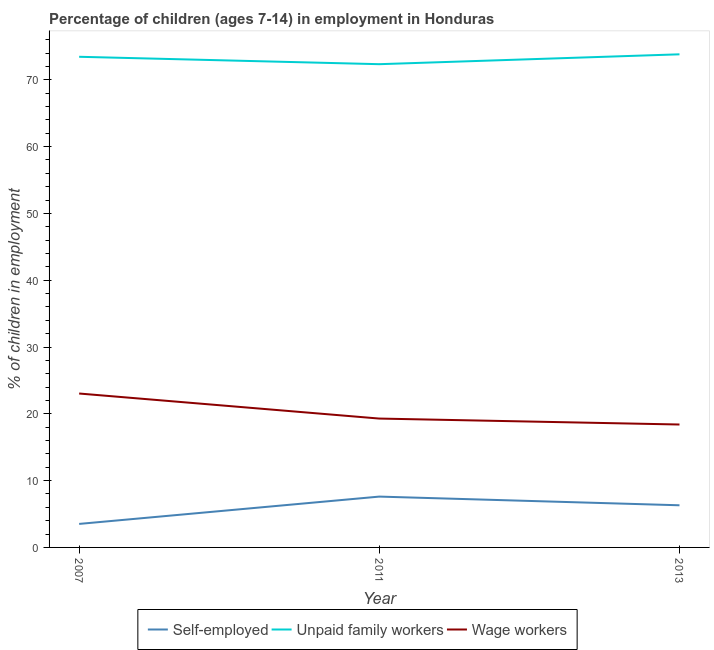How many different coloured lines are there?
Your answer should be compact. 3. Is the number of lines equal to the number of legend labels?
Give a very brief answer. Yes. What is the percentage of children employed as unpaid family workers in 2013?
Offer a terse response. 73.82. Across all years, what is the maximum percentage of self employed children?
Your response must be concise. 7.61. Across all years, what is the minimum percentage of children employed as wage workers?
Give a very brief answer. 18.4. In which year was the percentage of children employed as unpaid family workers minimum?
Ensure brevity in your answer.  2011. What is the total percentage of children employed as unpaid family workers in the graph?
Offer a very short reply. 219.61. What is the difference between the percentage of children employed as wage workers in 2011 and that in 2013?
Your response must be concise. 0.89. What is the difference between the percentage of self employed children in 2013 and the percentage of children employed as unpaid family workers in 2007?
Ensure brevity in your answer.  -67.14. What is the average percentage of children employed as wage workers per year?
Your answer should be very brief. 20.24. In the year 2007, what is the difference between the percentage of children employed as unpaid family workers and percentage of children employed as wage workers?
Your answer should be compact. 50.41. What is the ratio of the percentage of self employed children in 2007 to that in 2013?
Your answer should be compact. 0.56. Is the percentage of self employed children in 2011 less than that in 2013?
Provide a succinct answer. No. Is the difference between the percentage of children employed as wage workers in 2011 and 2013 greater than the difference between the percentage of self employed children in 2011 and 2013?
Make the answer very short. No. What is the difference between the highest and the second highest percentage of self employed children?
Your answer should be very brief. 1.3. What is the difference between the highest and the lowest percentage of children employed as unpaid family workers?
Keep it short and to the point. 1.48. In how many years, is the percentage of children employed as wage workers greater than the average percentage of children employed as wage workers taken over all years?
Give a very brief answer. 1. Does the percentage of children employed as unpaid family workers monotonically increase over the years?
Make the answer very short. No. Is the percentage of children employed as wage workers strictly greater than the percentage of self employed children over the years?
Offer a very short reply. Yes. Is the percentage of self employed children strictly less than the percentage of children employed as wage workers over the years?
Keep it short and to the point. Yes. How many years are there in the graph?
Provide a short and direct response. 3. What is the difference between two consecutive major ticks on the Y-axis?
Keep it short and to the point. 10. Does the graph contain any zero values?
Your answer should be very brief. No. Does the graph contain grids?
Ensure brevity in your answer.  No. Where does the legend appear in the graph?
Provide a short and direct response. Bottom center. How are the legend labels stacked?
Provide a succinct answer. Horizontal. What is the title of the graph?
Your answer should be very brief. Percentage of children (ages 7-14) in employment in Honduras. What is the label or title of the Y-axis?
Keep it short and to the point. % of children in employment. What is the % of children in employment of Self-employed in 2007?
Provide a succinct answer. 3.52. What is the % of children in employment in Unpaid family workers in 2007?
Your response must be concise. 73.45. What is the % of children in employment in Wage workers in 2007?
Your answer should be compact. 23.04. What is the % of children in employment in Self-employed in 2011?
Your answer should be very brief. 7.61. What is the % of children in employment of Unpaid family workers in 2011?
Provide a succinct answer. 72.34. What is the % of children in employment in Wage workers in 2011?
Offer a very short reply. 19.29. What is the % of children in employment in Self-employed in 2013?
Provide a succinct answer. 6.31. What is the % of children in employment in Unpaid family workers in 2013?
Keep it short and to the point. 73.82. Across all years, what is the maximum % of children in employment of Self-employed?
Provide a short and direct response. 7.61. Across all years, what is the maximum % of children in employment in Unpaid family workers?
Your answer should be compact. 73.82. Across all years, what is the maximum % of children in employment of Wage workers?
Make the answer very short. 23.04. Across all years, what is the minimum % of children in employment of Self-employed?
Offer a terse response. 3.52. Across all years, what is the minimum % of children in employment in Unpaid family workers?
Give a very brief answer. 72.34. What is the total % of children in employment in Self-employed in the graph?
Offer a very short reply. 17.44. What is the total % of children in employment of Unpaid family workers in the graph?
Keep it short and to the point. 219.61. What is the total % of children in employment in Wage workers in the graph?
Keep it short and to the point. 60.73. What is the difference between the % of children in employment in Self-employed in 2007 and that in 2011?
Your answer should be compact. -4.09. What is the difference between the % of children in employment of Unpaid family workers in 2007 and that in 2011?
Offer a terse response. 1.11. What is the difference between the % of children in employment of Wage workers in 2007 and that in 2011?
Ensure brevity in your answer.  3.75. What is the difference between the % of children in employment in Self-employed in 2007 and that in 2013?
Your answer should be compact. -2.79. What is the difference between the % of children in employment in Unpaid family workers in 2007 and that in 2013?
Ensure brevity in your answer.  -0.37. What is the difference between the % of children in employment of Wage workers in 2007 and that in 2013?
Ensure brevity in your answer.  4.64. What is the difference between the % of children in employment of Unpaid family workers in 2011 and that in 2013?
Offer a very short reply. -1.48. What is the difference between the % of children in employment of Wage workers in 2011 and that in 2013?
Provide a succinct answer. 0.89. What is the difference between the % of children in employment in Self-employed in 2007 and the % of children in employment in Unpaid family workers in 2011?
Provide a short and direct response. -68.82. What is the difference between the % of children in employment in Self-employed in 2007 and the % of children in employment in Wage workers in 2011?
Make the answer very short. -15.77. What is the difference between the % of children in employment of Unpaid family workers in 2007 and the % of children in employment of Wage workers in 2011?
Ensure brevity in your answer.  54.16. What is the difference between the % of children in employment of Self-employed in 2007 and the % of children in employment of Unpaid family workers in 2013?
Ensure brevity in your answer.  -70.3. What is the difference between the % of children in employment of Self-employed in 2007 and the % of children in employment of Wage workers in 2013?
Offer a terse response. -14.88. What is the difference between the % of children in employment of Unpaid family workers in 2007 and the % of children in employment of Wage workers in 2013?
Ensure brevity in your answer.  55.05. What is the difference between the % of children in employment in Self-employed in 2011 and the % of children in employment in Unpaid family workers in 2013?
Make the answer very short. -66.21. What is the difference between the % of children in employment in Self-employed in 2011 and the % of children in employment in Wage workers in 2013?
Make the answer very short. -10.79. What is the difference between the % of children in employment of Unpaid family workers in 2011 and the % of children in employment of Wage workers in 2013?
Provide a succinct answer. 53.94. What is the average % of children in employment in Self-employed per year?
Your answer should be compact. 5.81. What is the average % of children in employment in Unpaid family workers per year?
Your answer should be very brief. 73.2. What is the average % of children in employment in Wage workers per year?
Ensure brevity in your answer.  20.24. In the year 2007, what is the difference between the % of children in employment in Self-employed and % of children in employment in Unpaid family workers?
Make the answer very short. -69.93. In the year 2007, what is the difference between the % of children in employment in Self-employed and % of children in employment in Wage workers?
Your response must be concise. -19.52. In the year 2007, what is the difference between the % of children in employment of Unpaid family workers and % of children in employment of Wage workers?
Offer a terse response. 50.41. In the year 2011, what is the difference between the % of children in employment of Self-employed and % of children in employment of Unpaid family workers?
Provide a short and direct response. -64.73. In the year 2011, what is the difference between the % of children in employment of Self-employed and % of children in employment of Wage workers?
Offer a terse response. -11.68. In the year 2011, what is the difference between the % of children in employment of Unpaid family workers and % of children in employment of Wage workers?
Offer a terse response. 53.05. In the year 2013, what is the difference between the % of children in employment in Self-employed and % of children in employment in Unpaid family workers?
Keep it short and to the point. -67.51. In the year 2013, what is the difference between the % of children in employment of Self-employed and % of children in employment of Wage workers?
Your answer should be very brief. -12.09. In the year 2013, what is the difference between the % of children in employment of Unpaid family workers and % of children in employment of Wage workers?
Provide a succinct answer. 55.42. What is the ratio of the % of children in employment in Self-employed in 2007 to that in 2011?
Make the answer very short. 0.46. What is the ratio of the % of children in employment in Unpaid family workers in 2007 to that in 2011?
Ensure brevity in your answer.  1.02. What is the ratio of the % of children in employment in Wage workers in 2007 to that in 2011?
Your response must be concise. 1.19. What is the ratio of the % of children in employment in Self-employed in 2007 to that in 2013?
Your answer should be compact. 0.56. What is the ratio of the % of children in employment of Wage workers in 2007 to that in 2013?
Your response must be concise. 1.25. What is the ratio of the % of children in employment of Self-employed in 2011 to that in 2013?
Your response must be concise. 1.21. What is the ratio of the % of children in employment in Wage workers in 2011 to that in 2013?
Your answer should be compact. 1.05. What is the difference between the highest and the second highest % of children in employment in Unpaid family workers?
Keep it short and to the point. 0.37. What is the difference between the highest and the second highest % of children in employment of Wage workers?
Provide a succinct answer. 3.75. What is the difference between the highest and the lowest % of children in employment of Self-employed?
Provide a succinct answer. 4.09. What is the difference between the highest and the lowest % of children in employment in Unpaid family workers?
Your answer should be very brief. 1.48. What is the difference between the highest and the lowest % of children in employment of Wage workers?
Your answer should be very brief. 4.64. 